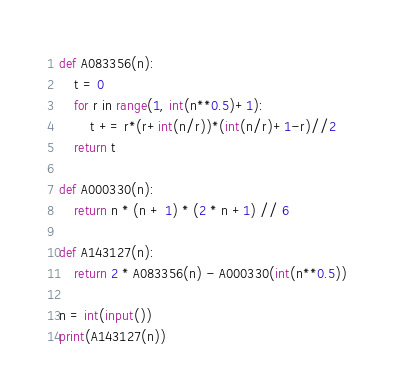Convert code to text. <code><loc_0><loc_0><loc_500><loc_500><_Python_>def A083356(n):
    t = 0
    for r in range(1, int(n**0.5)+1):
        t += r*(r+int(n/r))*(int(n/r)+1-r)//2
    return t

def A000330(n):
    return n * (n + 1) * (2 * n +1) // 6

def A143127(n):
    return 2 * A083356(n) - A000330(int(n**0.5))

n = int(input())
print(A143127(n))
</code> 